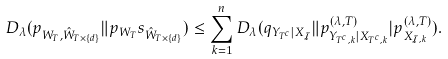<formula> <loc_0><loc_0><loc_500><loc_500>D _ { \lambda } ( p _ { W _ { T } , \hat { W } _ { T \times \{ d \} } } \| p _ { W _ { T } } s _ { \hat { W } _ { T \times \{ d \} } } ) \leq \sum _ { k = 1 } ^ { n } D _ { \lambda } ( q _ { Y _ { T ^ { c } } | X _ { \mathcal { I } } } \| p _ { Y _ { T ^ { c } , k } | X _ { T ^ { c } , k } } ^ { ( \lambda , T ) } | p _ { X _ { \mathcal { I } , k } } ^ { ( \lambda , T ) } ) .</formula> 